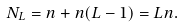Convert formula to latex. <formula><loc_0><loc_0><loc_500><loc_500>N _ { L } = n + n ( L - 1 ) = L n .</formula> 